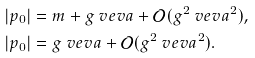Convert formula to latex. <formula><loc_0><loc_0><loc_500><loc_500>| p _ { 0 } | & = m + g \ v e v a + \mathcal { O } ( g ^ { 2 } \ v e v a ^ { 2 } ) , \\ | p _ { 0 } | & = g \ v e v a + \mathcal { O } ( g ^ { 2 } \ v e v a ^ { 2 } ) .</formula> 